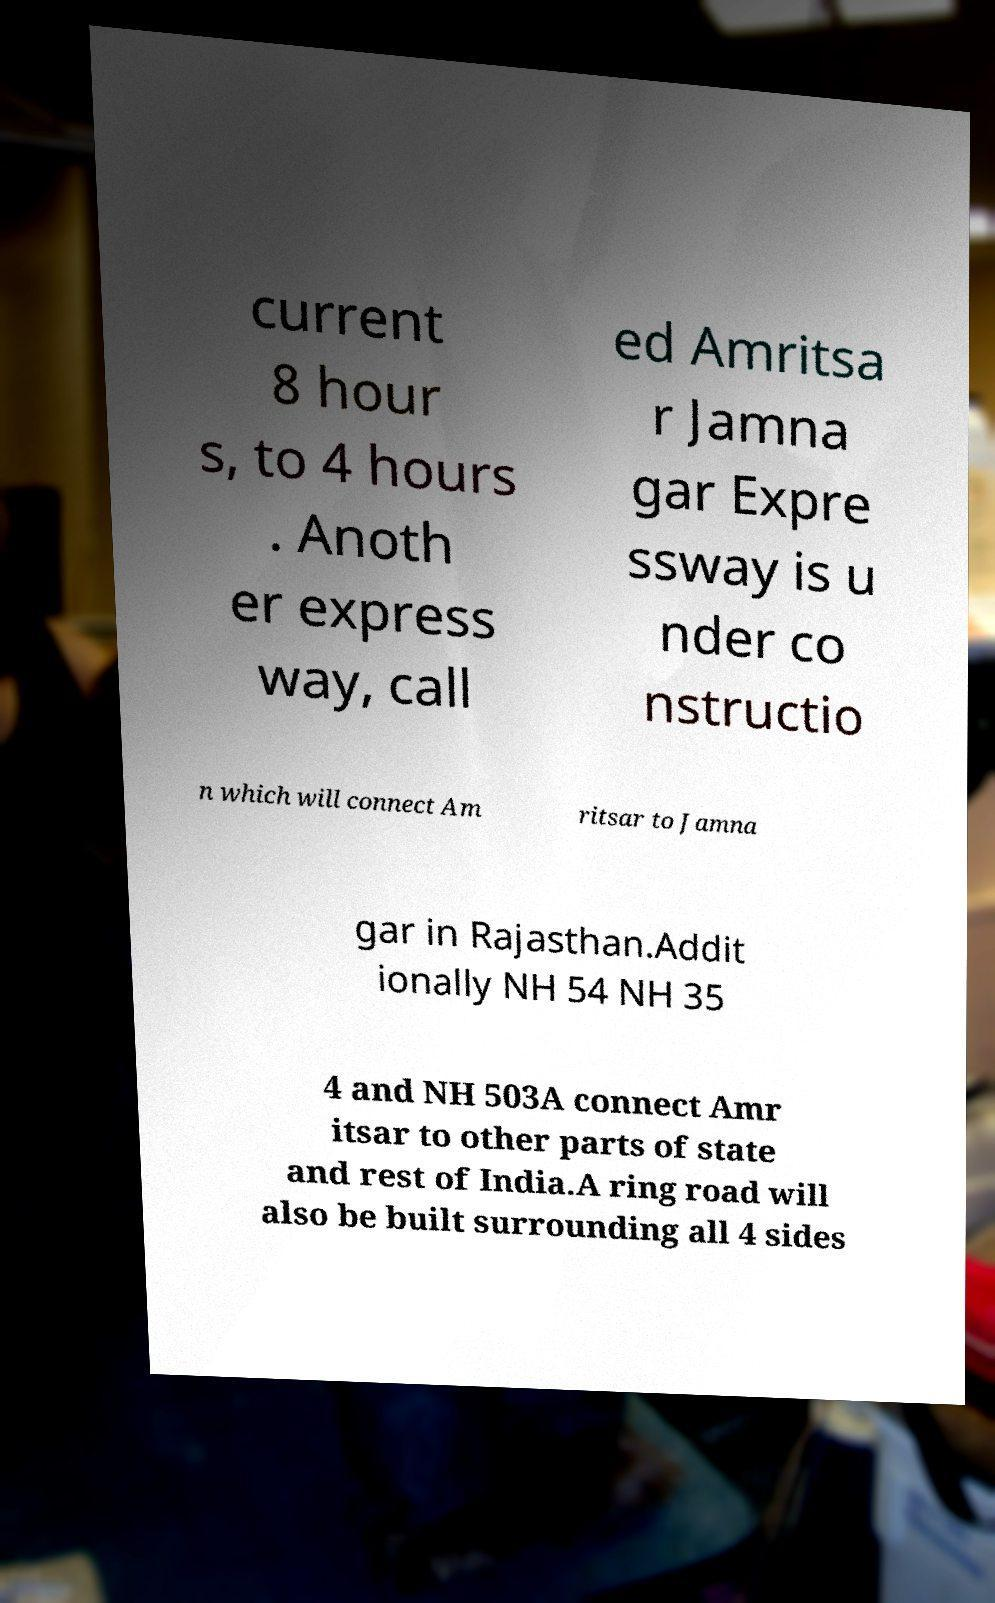Could you assist in decoding the text presented in this image and type it out clearly? current 8 hour s, to 4 hours . Anoth er express way, call ed Amritsa r Jamna gar Expre ssway is u nder co nstructio n which will connect Am ritsar to Jamna gar in Rajasthan.Addit ionally NH 54 NH 35 4 and NH 503A connect Amr itsar to other parts of state and rest of India.A ring road will also be built surrounding all 4 sides 